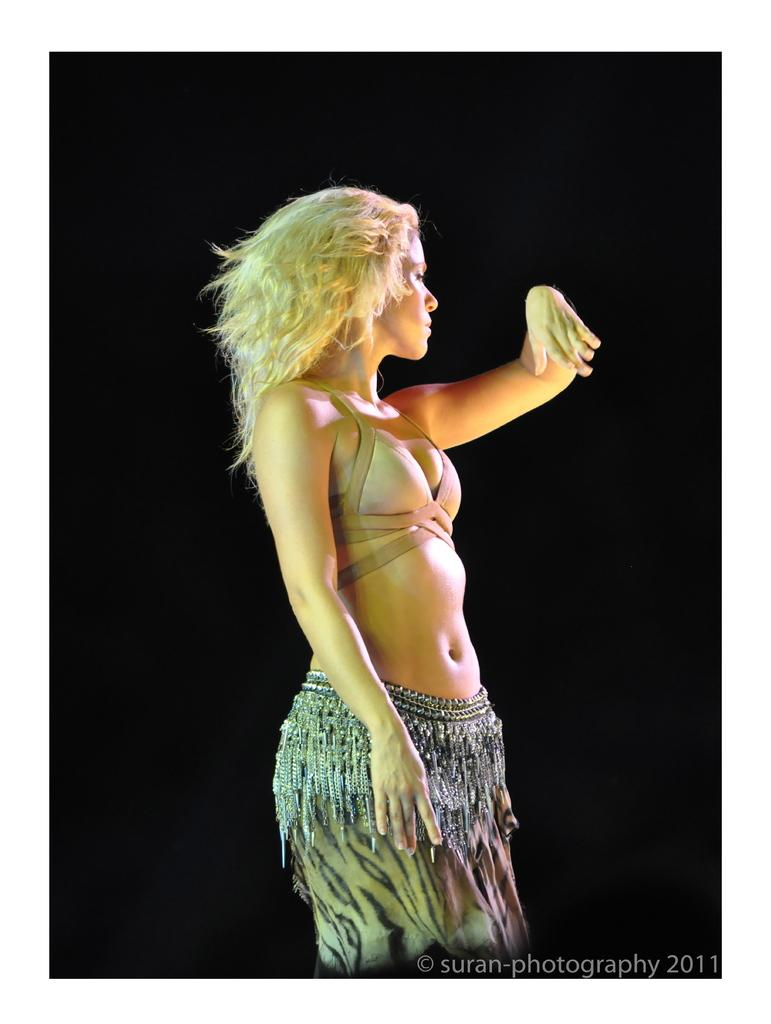Who is the main subject in the image? There is a lady in the image. Where is the lady positioned in the image? The lady is standing in the center of the image. What route does the squirrel take to reach the lady in the image? There is no squirrel present in the image, so there is no route to consider. 